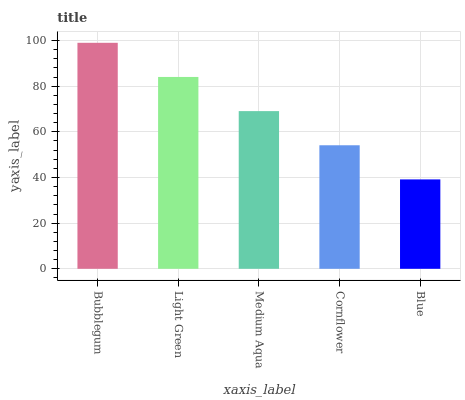Is Blue the minimum?
Answer yes or no. Yes. Is Bubblegum the maximum?
Answer yes or no. Yes. Is Light Green the minimum?
Answer yes or no. No. Is Light Green the maximum?
Answer yes or no. No. Is Bubblegum greater than Light Green?
Answer yes or no. Yes. Is Light Green less than Bubblegum?
Answer yes or no. Yes. Is Light Green greater than Bubblegum?
Answer yes or no. No. Is Bubblegum less than Light Green?
Answer yes or no. No. Is Medium Aqua the high median?
Answer yes or no. Yes. Is Medium Aqua the low median?
Answer yes or no. Yes. Is Bubblegum the high median?
Answer yes or no. No. Is Cornflower the low median?
Answer yes or no. No. 